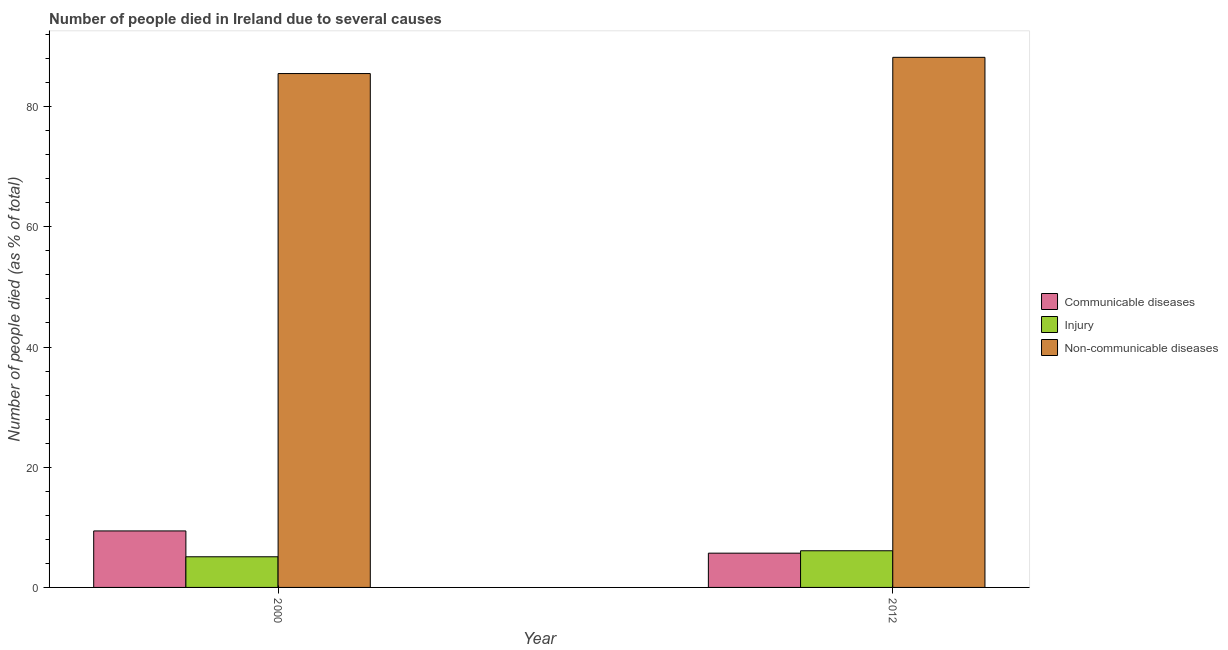Are the number of bars per tick equal to the number of legend labels?
Make the answer very short. Yes. Are the number of bars on each tick of the X-axis equal?
Give a very brief answer. Yes. In how many cases, is the number of bars for a given year not equal to the number of legend labels?
Ensure brevity in your answer.  0. What is the number of people who dies of non-communicable diseases in 2012?
Offer a very short reply. 88.2. What is the total number of people who died of communicable diseases in the graph?
Keep it short and to the point. 15.1. What is the difference between the number of people who died of communicable diseases in 2000 and that in 2012?
Ensure brevity in your answer.  3.7. What is the difference between the number of people who dies of non-communicable diseases in 2000 and the number of people who died of injury in 2012?
Make the answer very short. -2.7. What is the average number of people who died of communicable diseases per year?
Offer a very short reply. 7.55. What is the ratio of the number of people who dies of non-communicable diseases in 2000 to that in 2012?
Provide a succinct answer. 0.97. Is the number of people who died of communicable diseases in 2000 less than that in 2012?
Offer a terse response. No. In how many years, is the number of people who died of communicable diseases greater than the average number of people who died of communicable diseases taken over all years?
Give a very brief answer. 1. What does the 1st bar from the left in 2012 represents?
Provide a short and direct response. Communicable diseases. What does the 3rd bar from the right in 2000 represents?
Keep it short and to the point. Communicable diseases. Are all the bars in the graph horizontal?
Offer a terse response. No. How many years are there in the graph?
Provide a short and direct response. 2. What is the difference between two consecutive major ticks on the Y-axis?
Provide a succinct answer. 20. How many legend labels are there?
Offer a very short reply. 3. How are the legend labels stacked?
Your response must be concise. Vertical. What is the title of the graph?
Provide a short and direct response. Number of people died in Ireland due to several causes. What is the label or title of the X-axis?
Your answer should be very brief. Year. What is the label or title of the Y-axis?
Offer a terse response. Number of people died (as % of total). What is the Number of people died (as % of total) in Communicable diseases in 2000?
Provide a short and direct response. 9.4. What is the Number of people died (as % of total) in Non-communicable diseases in 2000?
Make the answer very short. 85.5. What is the Number of people died (as % of total) of Injury in 2012?
Provide a short and direct response. 6.1. What is the Number of people died (as % of total) in Non-communicable diseases in 2012?
Offer a very short reply. 88.2. Across all years, what is the maximum Number of people died (as % of total) of Communicable diseases?
Your answer should be very brief. 9.4. Across all years, what is the maximum Number of people died (as % of total) in Injury?
Keep it short and to the point. 6.1. Across all years, what is the maximum Number of people died (as % of total) of Non-communicable diseases?
Give a very brief answer. 88.2. Across all years, what is the minimum Number of people died (as % of total) in Non-communicable diseases?
Ensure brevity in your answer.  85.5. What is the total Number of people died (as % of total) of Non-communicable diseases in the graph?
Offer a very short reply. 173.7. What is the difference between the Number of people died (as % of total) in Communicable diseases in 2000 and that in 2012?
Ensure brevity in your answer.  3.7. What is the difference between the Number of people died (as % of total) of Communicable diseases in 2000 and the Number of people died (as % of total) of Non-communicable diseases in 2012?
Offer a very short reply. -78.8. What is the difference between the Number of people died (as % of total) of Injury in 2000 and the Number of people died (as % of total) of Non-communicable diseases in 2012?
Offer a terse response. -83.1. What is the average Number of people died (as % of total) in Communicable diseases per year?
Offer a very short reply. 7.55. What is the average Number of people died (as % of total) of Non-communicable diseases per year?
Ensure brevity in your answer.  86.85. In the year 2000, what is the difference between the Number of people died (as % of total) in Communicable diseases and Number of people died (as % of total) in Non-communicable diseases?
Provide a succinct answer. -76.1. In the year 2000, what is the difference between the Number of people died (as % of total) in Injury and Number of people died (as % of total) in Non-communicable diseases?
Ensure brevity in your answer.  -80.4. In the year 2012, what is the difference between the Number of people died (as % of total) in Communicable diseases and Number of people died (as % of total) in Non-communicable diseases?
Your answer should be very brief. -82.5. In the year 2012, what is the difference between the Number of people died (as % of total) in Injury and Number of people died (as % of total) in Non-communicable diseases?
Provide a short and direct response. -82.1. What is the ratio of the Number of people died (as % of total) in Communicable diseases in 2000 to that in 2012?
Offer a terse response. 1.65. What is the ratio of the Number of people died (as % of total) of Injury in 2000 to that in 2012?
Provide a succinct answer. 0.84. What is the ratio of the Number of people died (as % of total) in Non-communicable diseases in 2000 to that in 2012?
Offer a very short reply. 0.97. What is the difference between the highest and the second highest Number of people died (as % of total) in Injury?
Offer a very short reply. 1. What is the difference between the highest and the second highest Number of people died (as % of total) in Non-communicable diseases?
Your response must be concise. 2.7. What is the difference between the highest and the lowest Number of people died (as % of total) in Injury?
Offer a terse response. 1. 